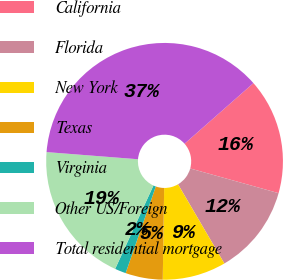Convert chart. <chart><loc_0><loc_0><loc_500><loc_500><pie_chart><fcel>California<fcel>Florida<fcel>New York<fcel>Texas<fcel>Virginia<fcel>Other US/Foreign<fcel>Total residential mortgage<nl><fcel>15.82%<fcel>12.24%<fcel>8.67%<fcel>5.09%<fcel>1.52%<fcel>19.39%<fcel>37.27%<nl></chart> 